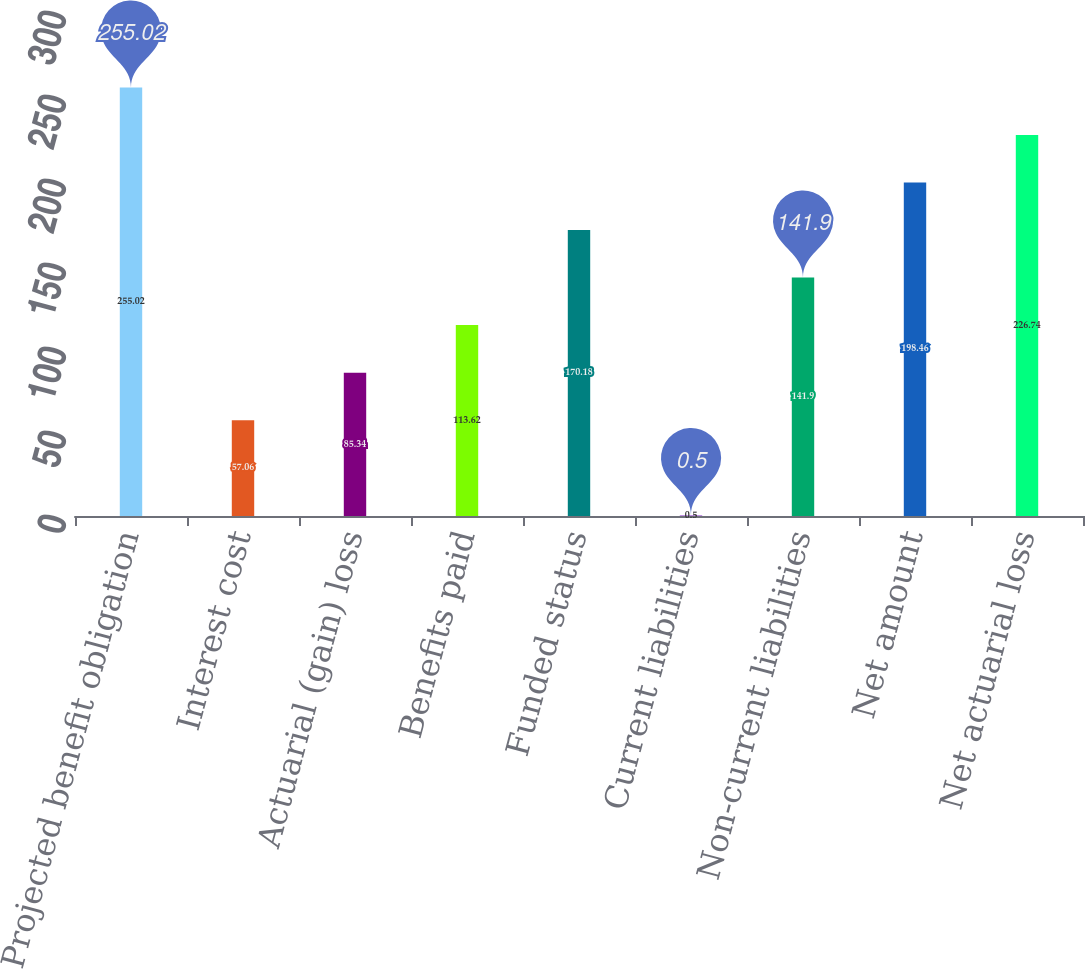Convert chart. <chart><loc_0><loc_0><loc_500><loc_500><bar_chart><fcel>Projected benefit obligation<fcel>Interest cost<fcel>Actuarial (gain) loss<fcel>Benefits paid<fcel>Funded status<fcel>Current liabilities<fcel>Non-current liabilities<fcel>Net amount<fcel>Net actuarial loss<nl><fcel>255.02<fcel>57.06<fcel>85.34<fcel>113.62<fcel>170.18<fcel>0.5<fcel>141.9<fcel>198.46<fcel>226.74<nl></chart> 